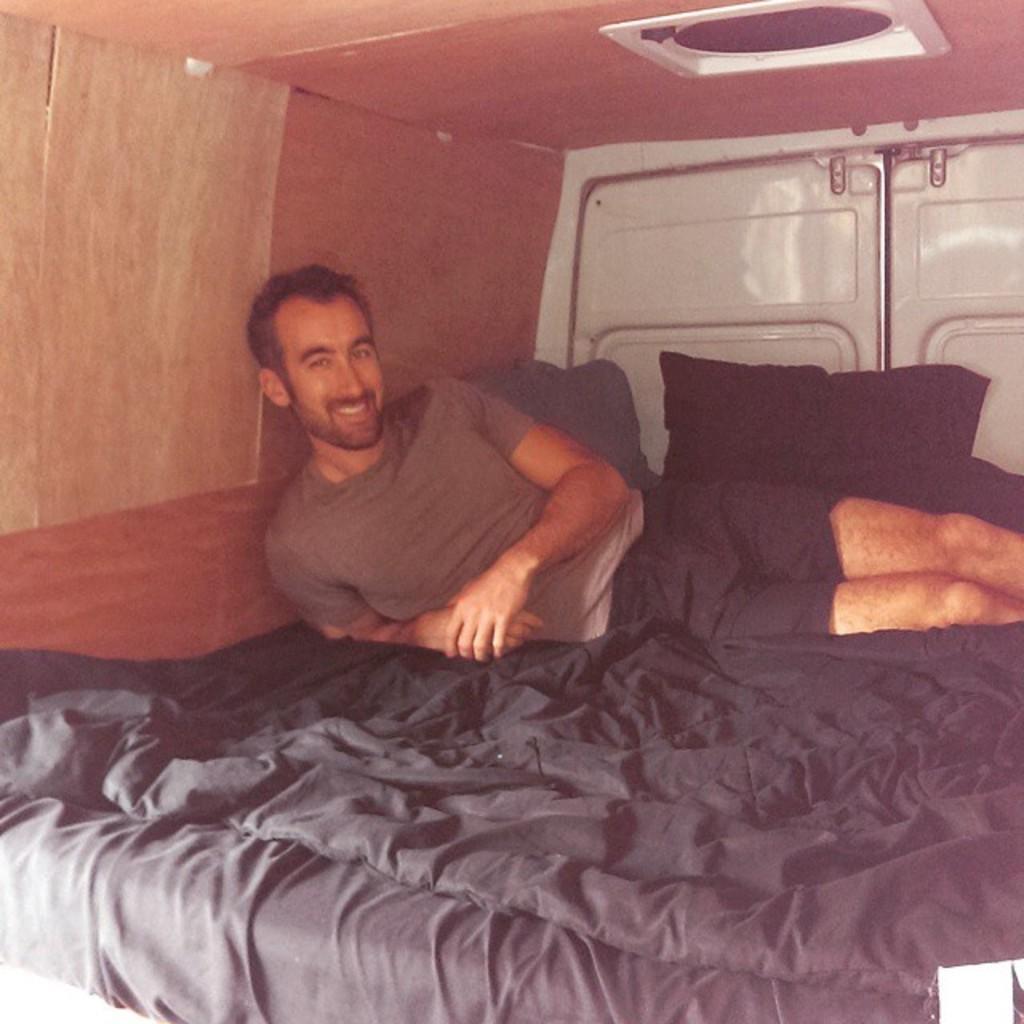How would you summarize this image in a sentence or two? There is a man laying on the bed. He wore a T-Shirt and a short he is smiling. This is the bed sheet here is the pillow. This is the roof. 